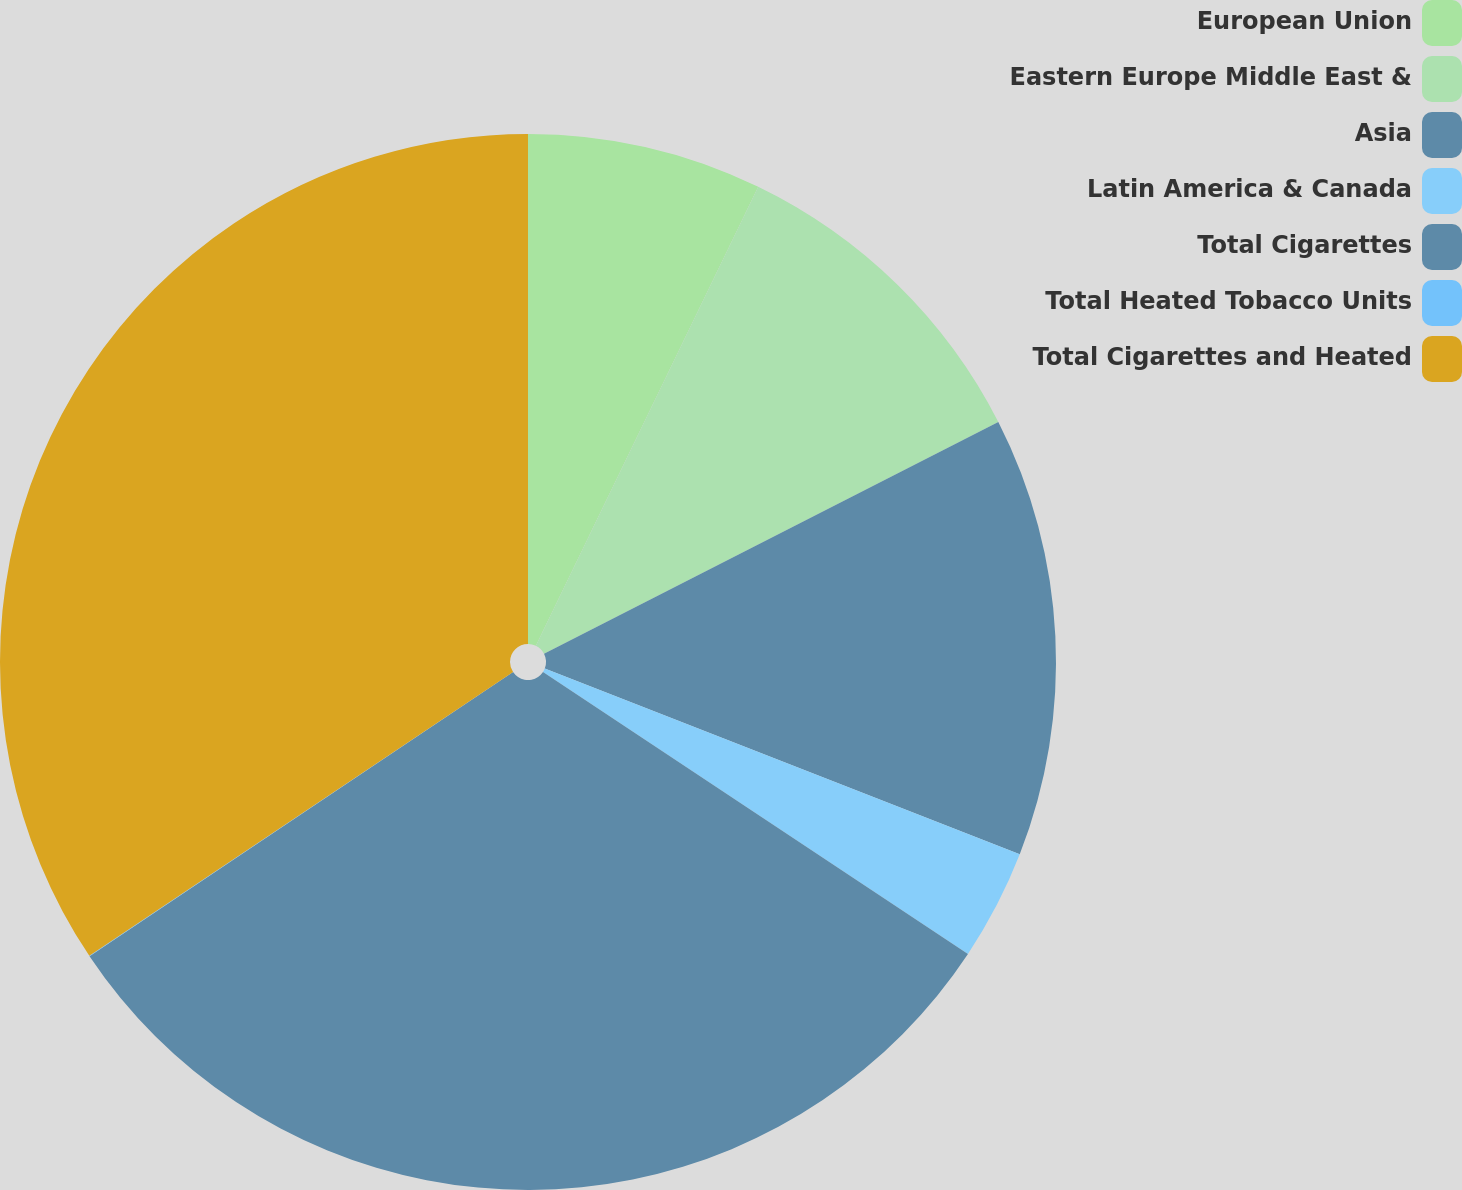Convert chart to OTSL. <chart><loc_0><loc_0><loc_500><loc_500><pie_chart><fcel>European Union<fcel>Eastern Europe Middle East &<fcel>Asia<fcel>Latin America & Canada<fcel>Total Cigarettes<fcel>Total Heated Tobacco Units<fcel>Total Cigarettes and Heated<nl><fcel>7.18%<fcel>10.31%<fcel>13.44%<fcel>3.39%<fcel>31.27%<fcel>0.01%<fcel>34.39%<nl></chart> 